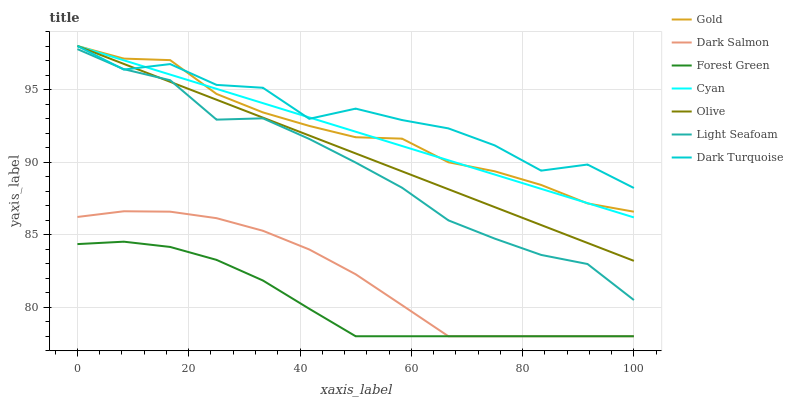Does Forest Green have the minimum area under the curve?
Answer yes or no. Yes. Does Dark Turquoise have the maximum area under the curve?
Answer yes or no. Yes. Does Dark Salmon have the minimum area under the curve?
Answer yes or no. No. Does Dark Salmon have the maximum area under the curve?
Answer yes or no. No. Is Cyan the smoothest?
Answer yes or no. Yes. Is Dark Turquoise the roughest?
Answer yes or no. Yes. Is Dark Salmon the smoothest?
Answer yes or no. No. Is Dark Salmon the roughest?
Answer yes or no. No. Does Dark Salmon have the lowest value?
Answer yes or no. Yes. Does Dark Turquoise have the lowest value?
Answer yes or no. No. Does Cyan have the highest value?
Answer yes or no. Yes. Does Dark Salmon have the highest value?
Answer yes or no. No. Is Forest Green less than Cyan?
Answer yes or no. Yes. Is Cyan greater than Dark Salmon?
Answer yes or no. Yes. Does Olive intersect Cyan?
Answer yes or no. Yes. Is Olive less than Cyan?
Answer yes or no. No. Is Olive greater than Cyan?
Answer yes or no. No. Does Forest Green intersect Cyan?
Answer yes or no. No. 